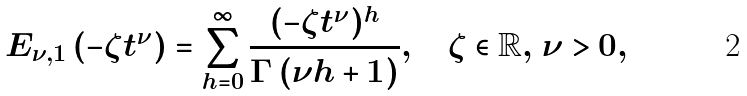Convert formula to latex. <formula><loc_0><loc_0><loc_500><loc_500>E _ { \nu , 1 } \left ( - \zeta t ^ { \nu } \right ) = \sum _ { h = 0 } ^ { \infty } \frac { ( - \zeta t ^ { \nu } ) ^ { h } } { \Gamma \left ( \nu h + 1 \right ) } , \quad \zeta \in \mathbb { R } , \, \nu > 0 ,</formula> 